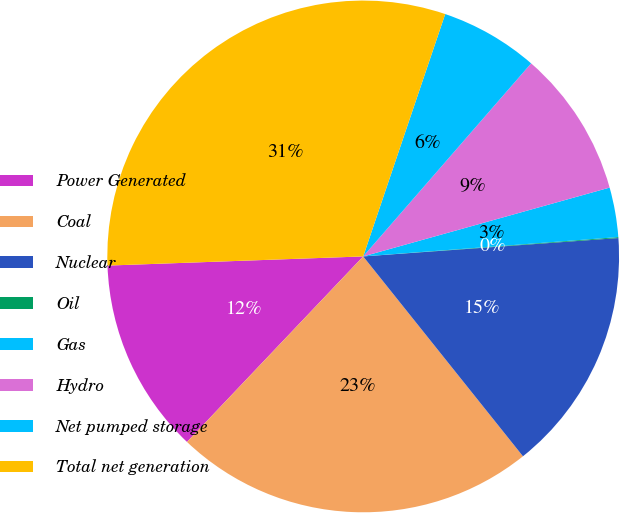Convert chart to OTSL. <chart><loc_0><loc_0><loc_500><loc_500><pie_chart><fcel>Power Generated<fcel>Coal<fcel>Nuclear<fcel>Oil<fcel>Gas<fcel>Hydro<fcel>Net pumped storage<fcel>Total net generation<nl><fcel>12.34%<fcel>22.82%<fcel>15.41%<fcel>0.06%<fcel>3.13%<fcel>9.27%<fcel>6.2%<fcel>30.76%<nl></chart> 